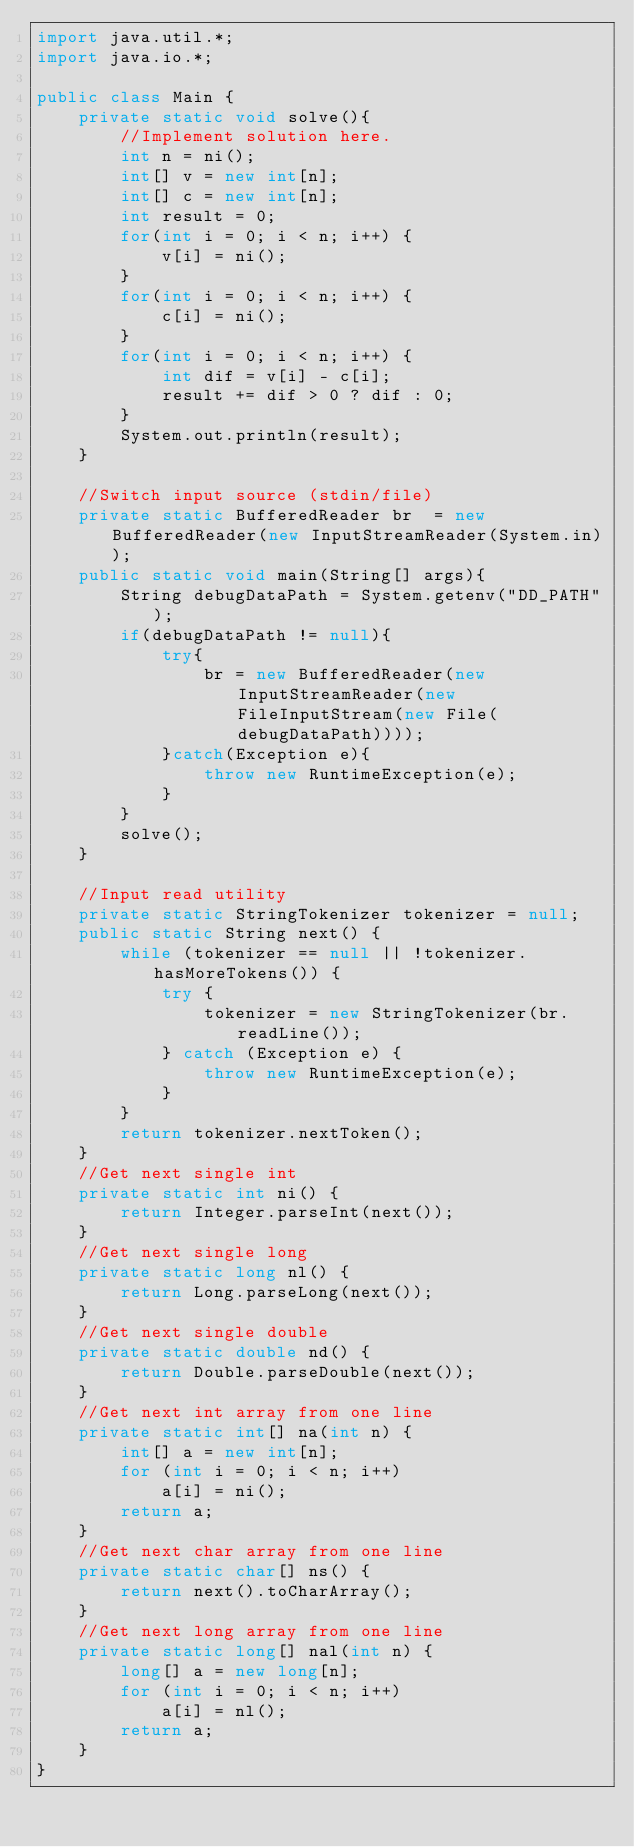Convert code to text. <code><loc_0><loc_0><loc_500><loc_500><_Java_>import java.util.*;
import java.io.*;

public class Main {
	private static void solve(){
		//Implement solution here.
		int n = ni();
		int[] v = new int[n];
		int[] c = new int[n];
		int result = 0;
		for(int i = 0; i < n; i++) {
			v[i] = ni();
		}
		for(int i = 0; i < n; i++) {
			c[i] = ni();
		}
		for(int i = 0; i < n; i++) {
			int dif = v[i] - c[i];
			result += dif > 0 ? dif : 0;
		}
		System.out.println(result);
	}

	//Switch input source (stdin/file)
	private static BufferedReader br  = new BufferedReader(new InputStreamReader(System.in));
	public static void main(String[] args){
		String debugDataPath = System.getenv("DD_PATH");        
		if(debugDataPath != null){
			try{
				br = new BufferedReader(new InputStreamReader(new FileInputStream(new File(debugDataPath))));
			}catch(Exception e){
				throw new RuntimeException(e);
			}
		}
		solve();
	}

	//Input read utility
	private static StringTokenizer tokenizer = null;
	public static String next() {
		while (tokenizer == null || !tokenizer.hasMoreTokens()) {
			try {
				tokenizer = new StringTokenizer(br.readLine());
			} catch (Exception e) {
				throw new RuntimeException(e);
			}
		}
		return tokenizer.nextToken();
	}
	//Get next single int
	private static int ni() {
		return Integer.parseInt(next());
	}
	//Get next single long
	private static long nl() {
		return Long.parseLong(next());
	}
	//Get next single double
	private static double nd() {
		return Double.parseDouble(next());
	}
	//Get next int array from one line
	private static int[] na(int n) {
		int[] a = new int[n];
		for (int i = 0; i < n; i++)
			a[i] = ni();
		return a;
	}
	//Get next char array from one line
	private static char[] ns() {
		return next().toCharArray();
	}
	//Get next long array from one line
	private static long[] nal(int n) {
		long[] a = new long[n];
		for (int i = 0; i < n; i++)
			a[i] = nl();
		return a;
	}
}</code> 